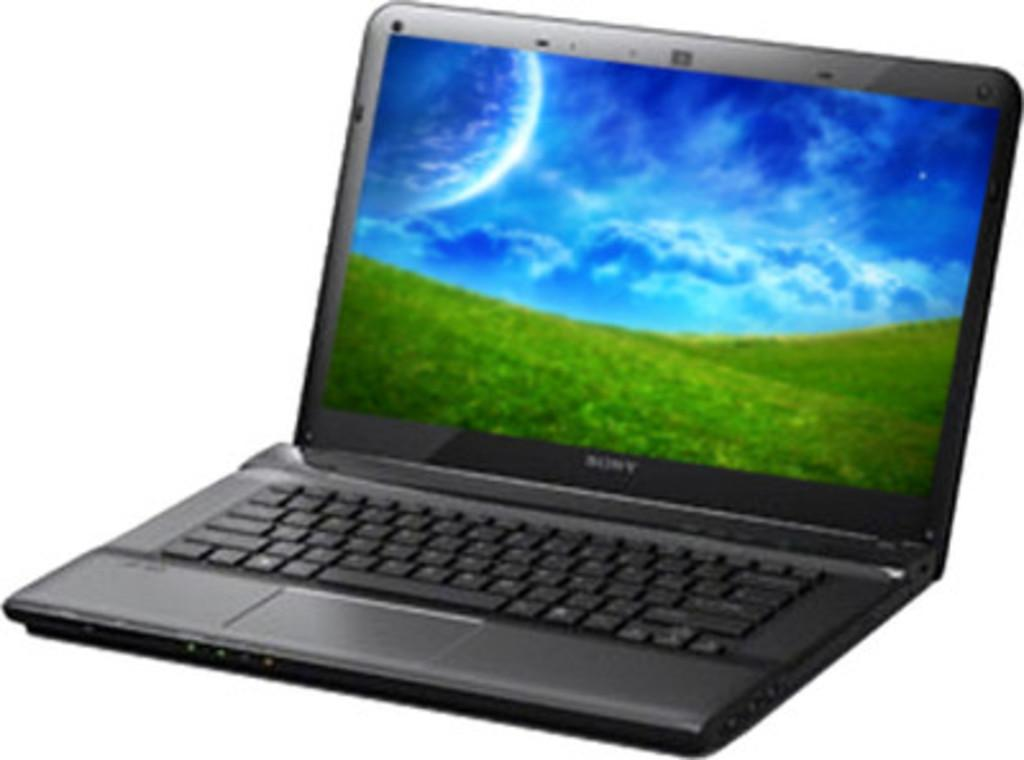Provide a one-sentence caption for the provided image. A Sony laptop displays a field with a large planet in the sky. 